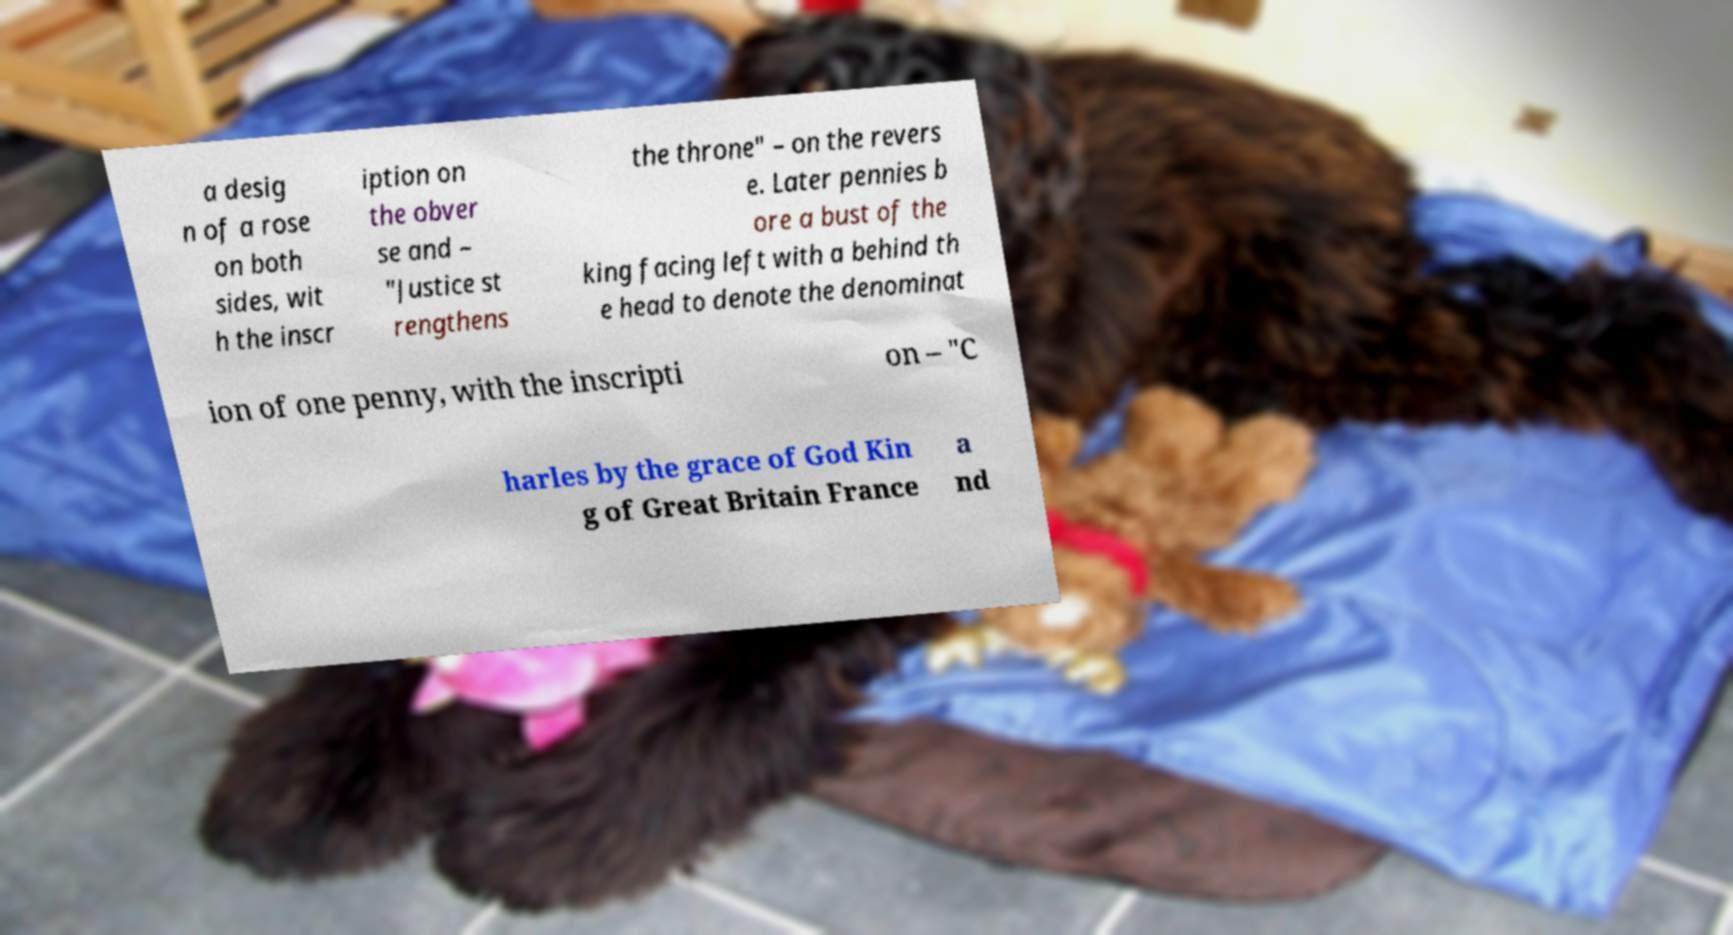What messages or text are displayed in this image? I need them in a readable, typed format. a desig n of a rose on both sides, wit h the inscr iption on the obver se and – "Justice st rengthens the throne" – on the revers e. Later pennies b ore a bust of the king facing left with a behind th e head to denote the denominat ion of one penny, with the inscripti on – "C harles by the grace of God Kin g of Great Britain France a nd 